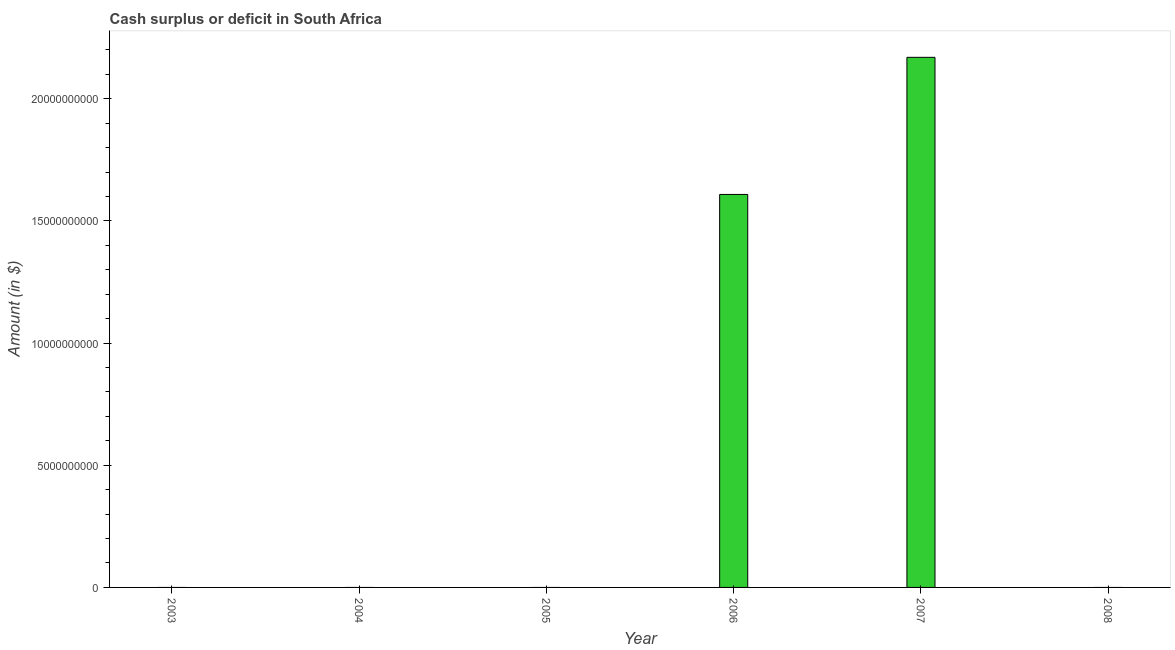Does the graph contain any zero values?
Offer a very short reply. Yes. What is the title of the graph?
Offer a very short reply. Cash surplus or deficit in South Africa. What is the label or title of the X-axis?
Your answer should be compact. Year. What is the label or title of the Y-axis?
Provide a succinct answer. Amount (in $). Across all years, what is the maximum cash surplus or deficit?
Provide a succinct answer. 2.17e+1. Across all years, what is the minimum cash surplus or deficit?
Ensure brevity in your answer.  0. What is the sum of the cash surplus or deficit?
Provide a short and direct response. 3.78e+1. What is the average cash surplus or deficit per year?
Provide a succinct answer. 6.30e+09. In how many years, is the cash surplus or deficit greater than 11000000000 $?
Provide a succinct answer. 2. What is the difference between the highest and the lowest cash surplus or deficit?
Provide a succinct answer. 2.17e+1. Are all the bars in the graph horizontal?
Your response must be concise. No. How many years are there in the graph?
Your answer should be compact. 6. What is the difference between two consecutive major ticks on the Y-axis?
Offer a very short reply. 5.00e+09. Are the values on the major ticks of Y-axis written in scientific E-notation?
Your answer should be compact. No. What is the Amount (in $) in 2006?
Offer a very short reply. 1.61e+1. What is the Amount (in $) in 2007?
Your answer should be compact. 2.17e+1. What is the difference between the Amount (in $) in 2006 and 2007?
Ensure brevity in your answer.  -5.61e+09. What is the ratio of the Amount (in $) in 2006 to that in 2007?
Ensure brevity in your answer.  0.74. 